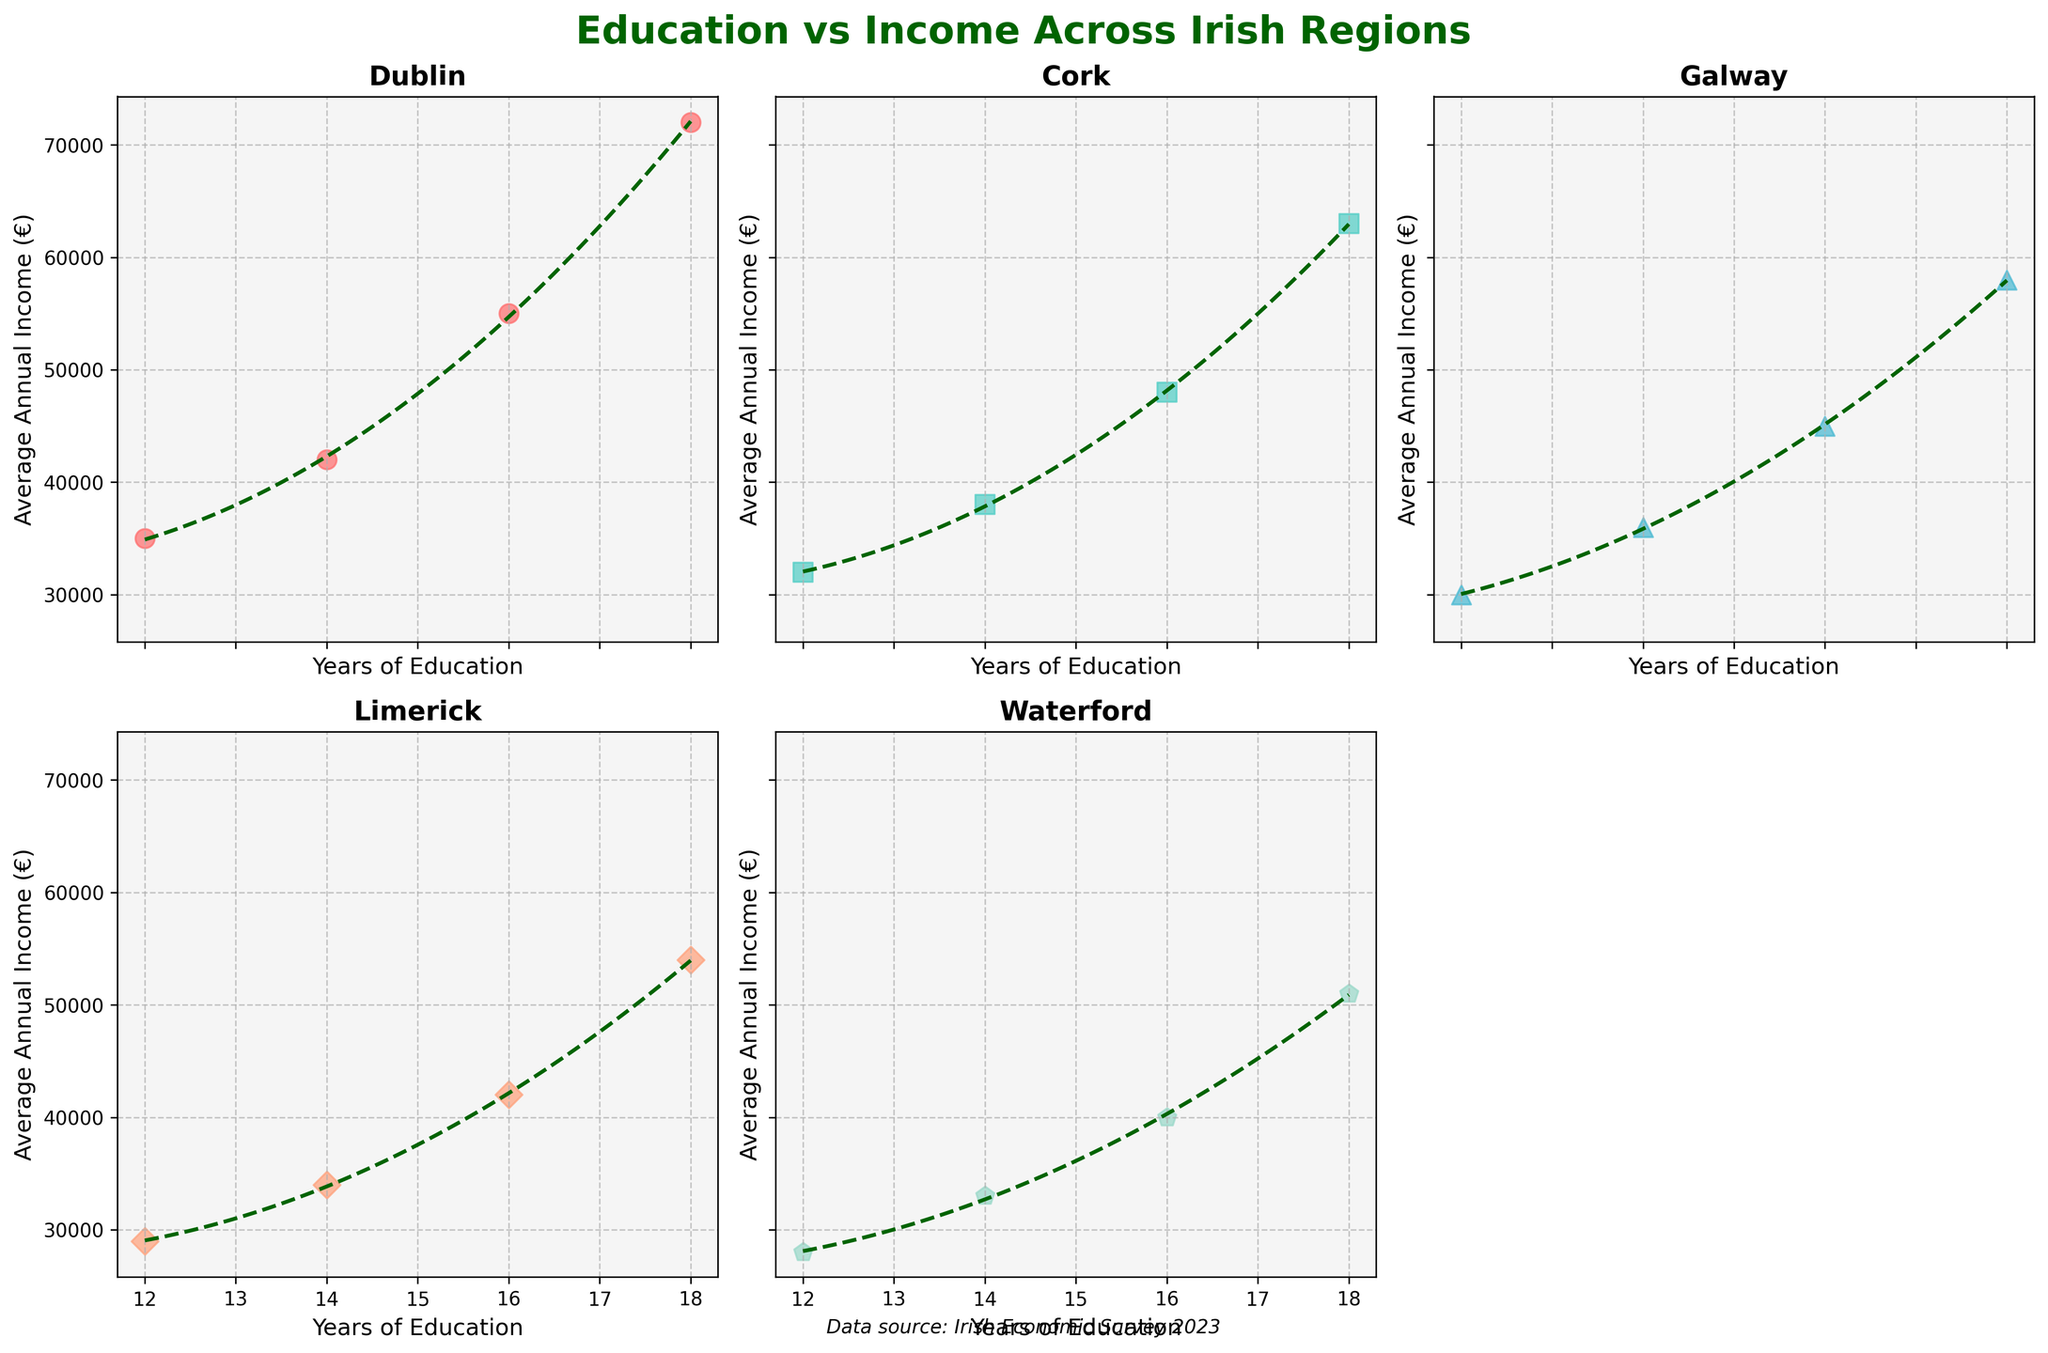Which region has the highest average annual income at 18 years of education? According to the plot, Dublin has the highest average annual income at 18 years of education, indicated by the top point on the y-axis.
Answer: Dublin What is the trend observed in the plots across all regions? By looking at the plots, one can see a positive correlation between years of education and average annual income in all regions. The trend lines fitted in each scatter plot also indicate an upward trend.
Answer: Positive correlation How many regions are represented in the scatter plots? The plots feature five regions: Dublin, Cork, Galway, Limerick, and Waterford. There are five scatter plots, one for each region.
Answer: Five Which regions have data points for average annual income below €30,000? The scatter plots for Limerick and Waterford have data points that are below the €30,000 mark, specifically around the 12 years of education mark.
Answer: Limerick and Waterford What is the difference in average annual income between Dublin and Cork for 14 years of education? The average annual income for Dublin at 14 years of education is €42,000, while for Cork it is €38,000. The difference is €42,000 - €38,000.
Answer: €4,000 Do any of the regions show a polynomial regression line fitted to the data? Yes, all regions show a polynomial regression line fitted to the data, which is a curve that attempts to best capture the trend of the scatter points.
Answer: Yes What colors are used for the scatter points in the Dublin and Galway plots? The scatter points for Dublin are red, while the scatter points for Galway are cyan. These colors help to distinguish different regions in the plots.
Answer: Red for Dublin and Cyan for Galway How is the X-axis labeled in each scatter plot? The X-axis in each scatter plot is labeled as "Years of Education," indicating the independent variable being plotted.
Answer: Years of Education What region has the least upward trend in average annual income with increasing years of education? By examining the slopes of the trend lines, Waterford appears to have the least steep increase, suggesting the smallest gain in average annual income with additional years of education.
Answer: Waterford 